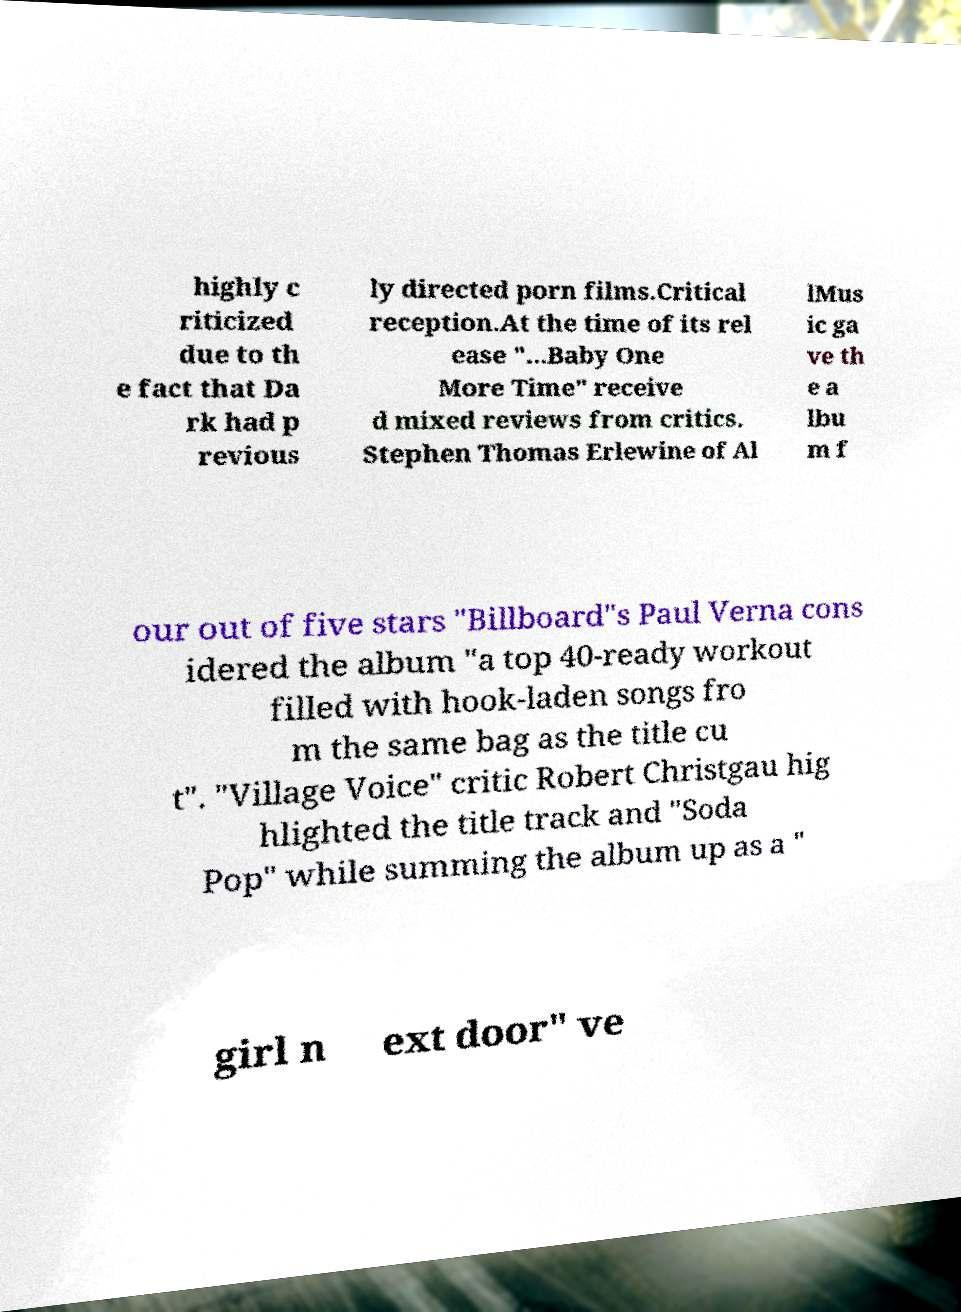Please identify and transcribe the text found in this image. highly c riticized due to th e fact that Da rk had p revious ly directed porn films.Critical reception.At the time of its rel ease "...Baby One More Time" receive d mixed reviews from critics. Stephen Thomas Erlewine of Al lMus ic ga ve th e a lbu m f our out of five stars "Billboard"s Paul Verna cons idered the album "a top 40-ready workout filled with hook-laden songs fro m the same bag as the title cu t". "Village Voice" critic Robert Christgau hig hlighted the title track and "Soda Pop" while summing the album up as a " girl n ext door" ve 